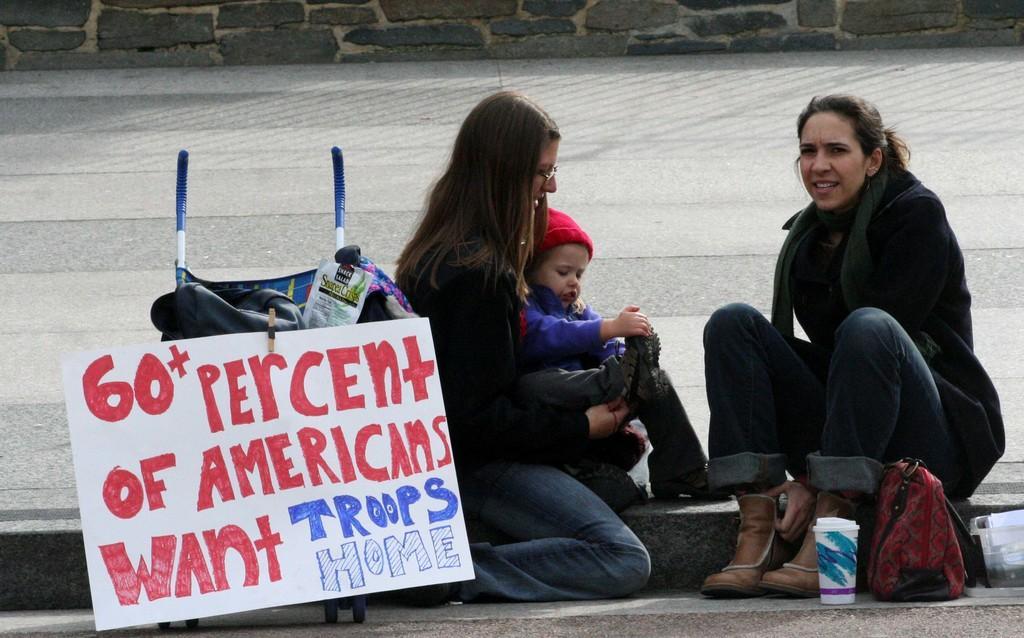Can you describe this image briefly? In this image I see 2 women who are sitting and I can also see this woman is holding a child. I can also see there is a bag over here, a cup and a paper. In the background I see the path and the wall. 